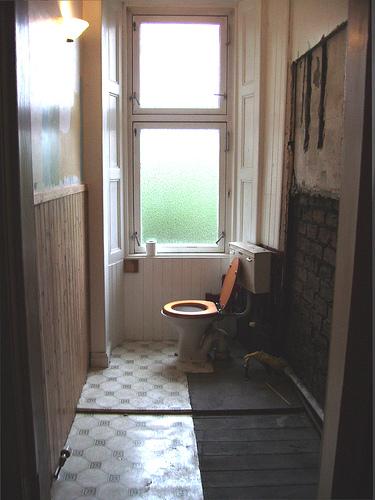Are the windows frosted?
Write a very short answer. Yes. What type of flooring is shown?
Write a very short answer. Tile. What color is the bathroom's wall?
Short answer required. White. What is on the window ledge?
Answer briefly. Toilet paper. What is the robe made out of?
Write a very short answer. No robe. 